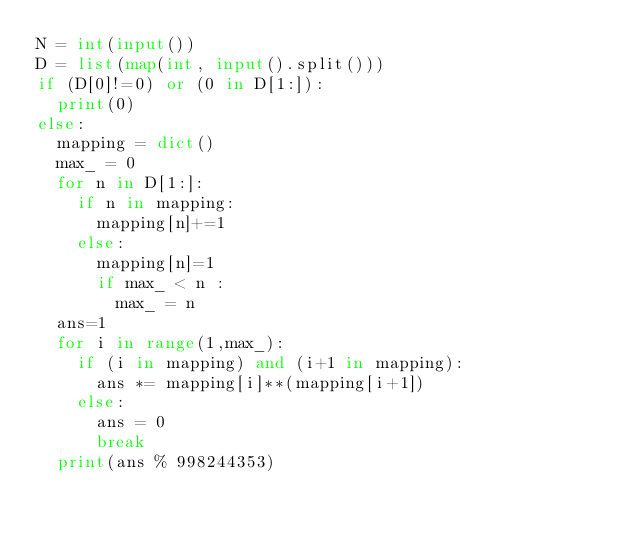Convert code to text. <code><loc_0><loc_0><loc_500><loc_500><_Python_>N = int(input())
D = list(map(int, input().split()))
if (D[0]!=0) or (0 in D[1:]):
  print(0)
else:
  mapping = dict()
  max_ = 0
  for n in D[1:]:
    if n in mapping:
      mapping[n]+=1
    else:
      mapping[n]=1
      if max_ < n :
        max_ = n
  ans=1
  for i in range(1,max_):
    if (i in mapping) and (i+1 in mapping):
      ans *= mapping[i]**(mapping[i+1])
    else:
      ans = 0
      break
  print(ans % 998244353)</code> 